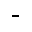<formula> <loc_0><loc_0><loc_500><loc_500>^ { - }</formula> 